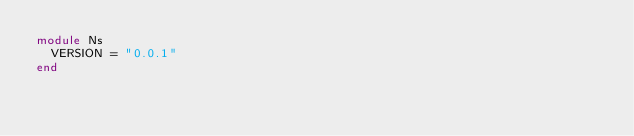Convert code to text. <code><loc_0><loc_0><loc_500><loc_500><_Ruby_>module Ns
  VERSION = "0.0.1"
end
</code> 